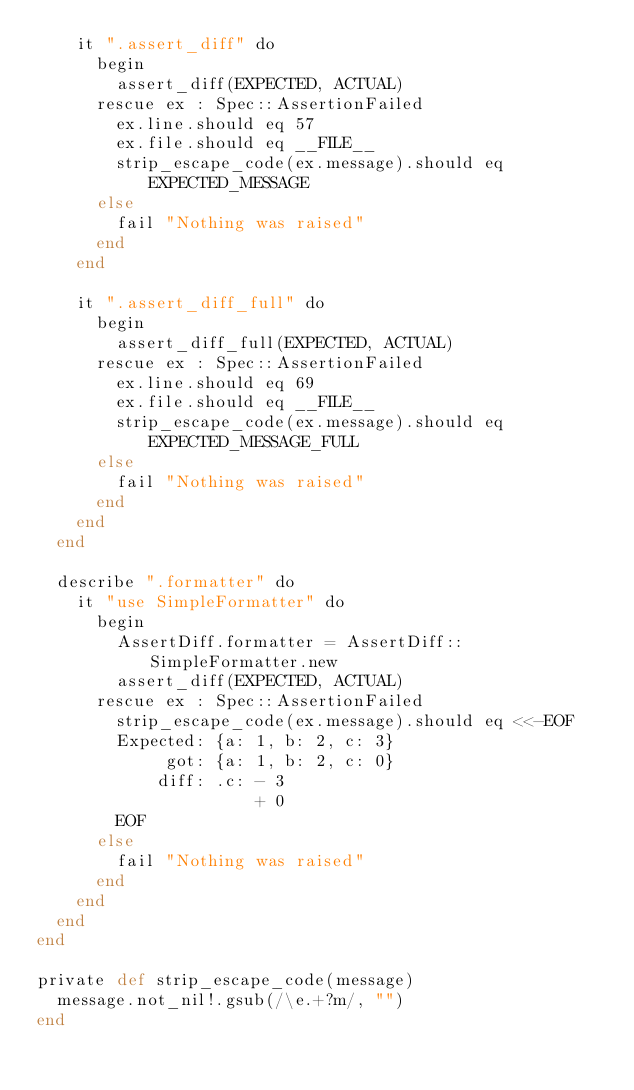Convert code to text. <code><loc_0><loc_0><loc_500><loc_500><_Crystal_>    it ".assert_diff" do
      begin
        assert_diff(EXPECTED, ACTUAL)
      rescue ex : Spec::AssertionFailed
        ex.line.should eq 57
        ex.file.should eq __FILE__
        strip_escape_code(ex.message).should eq EXPECTED_MESSAGE
      else
        fail "Nothing was raised"
      end
    end

    it ".assert_diff_full" do
      begin
        assert_diff_full(EXPECTED, ACTUAL)
      rescue ex : Spec::AssertionFailed
        ex.line.should eq 69
        ex.file.should eq __FILE__
        strip_escape_code(ex.message).should eq EXPECTED_MESSAGE_FULL
      else
        fail "Nothing was raised"
      end
    end
  end

  describe ".formatter" do
    it "use SimpleFormatter" do
      begin
        AssertDiff.formatter = AssertDiff::SimpleFormatter.new
        assert_diff(EXPECTED, ACTUAL)
      rescue ex : Spec::AssertionFailed
        strip_escape_code(ex.message).should eq <<-EOF
        Expected: {a: 1, b: 2, c: 3}
             got: {a: 1, b: 2, c: 0}
            diff: .c: - 3
                      + 0
        EOF
      else
        fail "Nothing was raised"
      end
    end
  end
end

private def strip_escape_code(message)
  message.not_nil!.gsub(/\e.+?m/, "")
end
</code> 